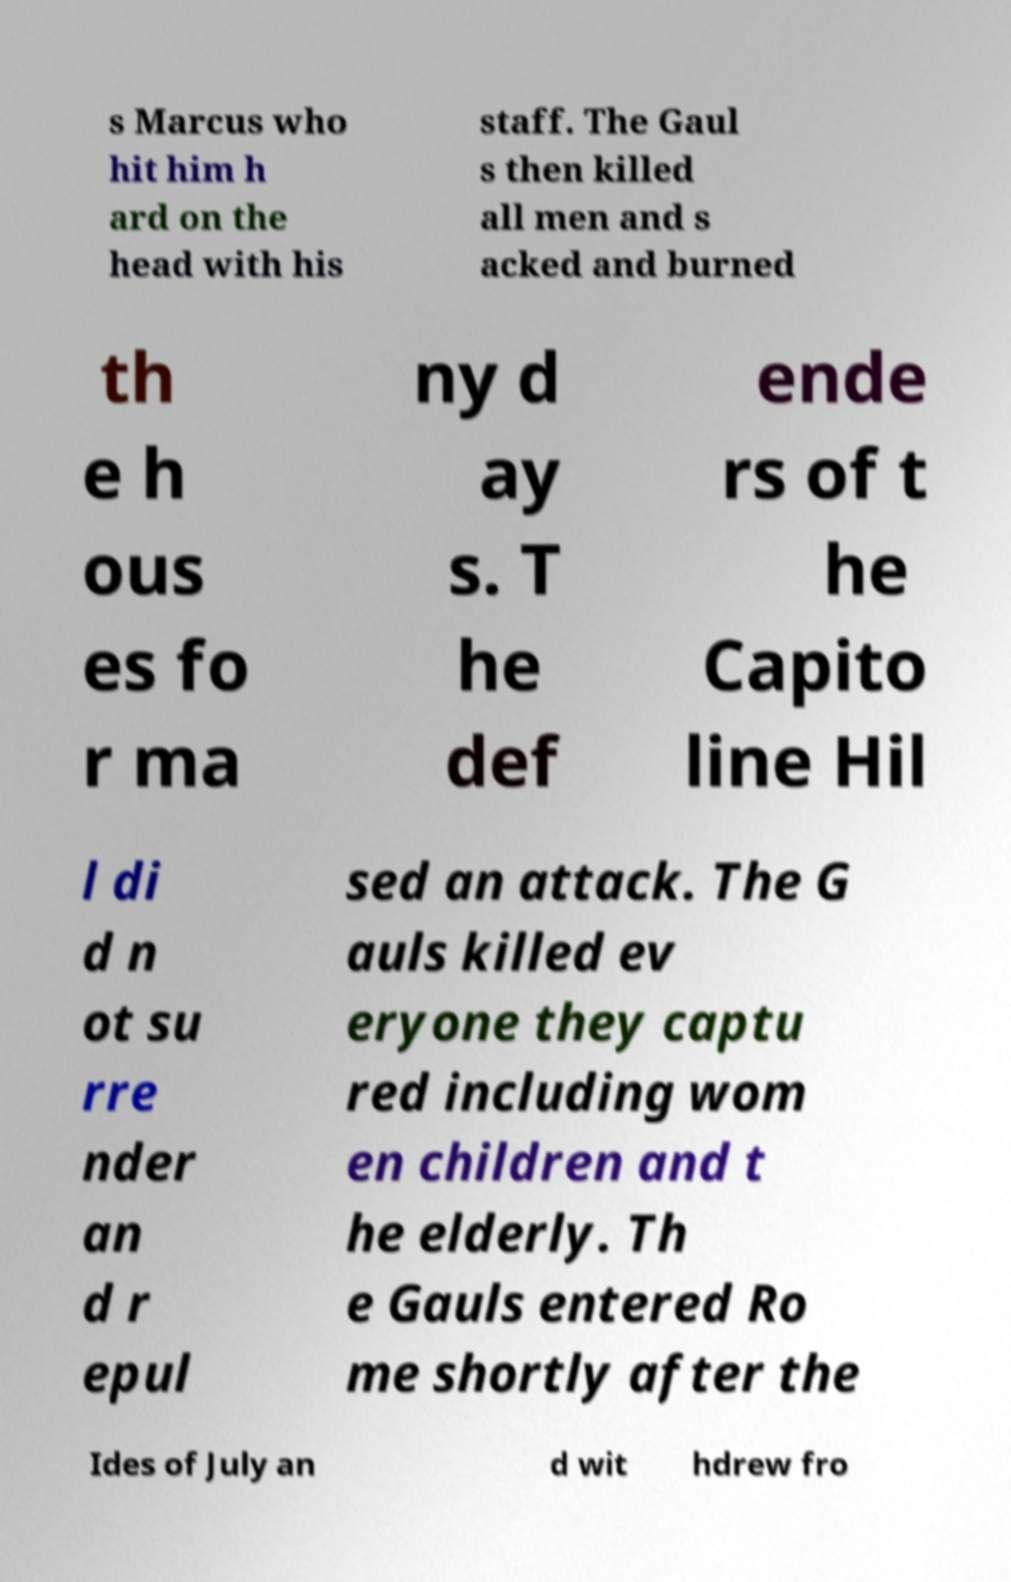Could you extract and type out the text from this image? s Marcus who hit him h ard on the head with his staff. The Gaul s then killed all men and s acked and burned th e h ous es fo r ma ny d ay s. T he def ende rs of t he Capito line Hil l di d n ot su rre nder an d r epul sed an attack. The G auls killed ev eryone they captu red including wom en children and t he elderly. Th e Gauls entered Ro me shortly after the Ides of July an d wit hdrew fro 